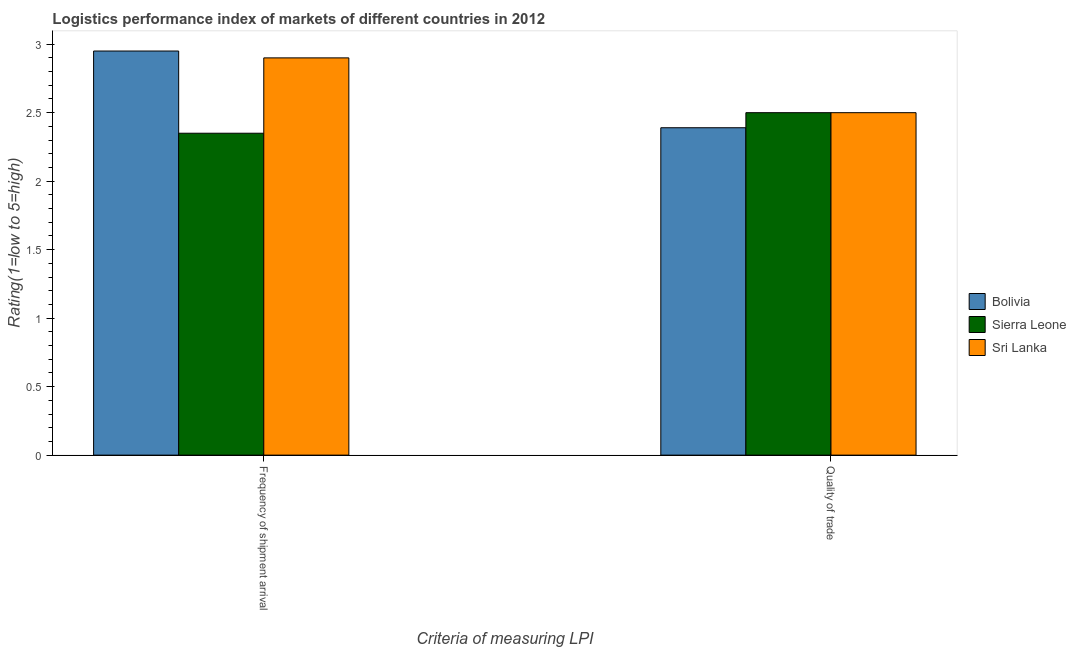How many groups of bars are there?
Provide a short and direct response. 2. Are the number of bars per tick equal to the number of legend labels?
Ensure brevity in your answer.  Yes. Are the number of bars on each tick of the X-axis equal?
Give a very brief answer. Yes. How many bars are there on the 2nd tick from the right?
Offer a terse response. 3. What is the label of the 1st group of bars from the left?
Offer a terse response. Frequency of shipment arrival. What is the lpi quality of trade in Sri Lanka?
Offer a very short reply. 2.5. Across all countries, what is the minimum lpi quality of trade?
Provide a short and direct response. 2.39. In which country was the lpi quality of trade maximum?
Give a very brief answer. Sierra Leone. In which country was the lpi quality of trade minimum?
Offer a terse response. Bolivia. What is the total lpi quality of trade in the graph?
Ensure brevity in your answer.  7.39. What is the difference between the lpi quality of trade in Bolivia and the lpi of frequency of shipment arrival in Sierra Leone?
Your response must be concise. 0.04. What is the average lpi quality of trade per country?
Give a very brief answer. 2.46. What is the difference between the lpi quality of trade and lpi of frequency of shipment arrival in Sierra Leone?
Your answer should be very brief. 0.15. What is the ratio of the lpi quality of trade in Bolivia to that in Sri Lanka?
Offer a terse response. 0.96. What does the 2nd bar from the left in Quality of trade represents?
Keep it short and to the point. Sierra Leone. What does the 2nd bar from the right in Frequency of shipment arrival represents?
Ensure brevity in your answer.  Sierra Leone. How many bars are there?
Offer a terse response. 6. Are all the bars in the graph horizontal?
Give a very brief answer. No. Does the graph contain grids?
Make the answer very short. No. Where does the legend appear in the graph?
Offer a terse response. Center right. What is the title of the graph?
Keep it short and to the point. Logistics performance index of markets of different countries in 2012. What is the label or title of the X-axis?
Ensure brevity in your answer.  Criteria of measuring LPI. What is the label or title of the Y-axis?
Your response must be concise. Rating(1=low to 5=high). What is the Rating(1=low to 5=high) in Bolivia in Frequency of shipment arrival?
Your answer should be very brief. 2.95. What is the Rating(1=low to 5=high) in Sierra Leone in Frequency of shipment arrival?
Ensure brevity in your answer.  2.35. What is the Rating(1=low to 5=high) in Bolivia in Quality of trade?
Give a very brief answer. 2.39. Across all Criteria of measuring LPI, what is the maximum Rating(1=low to 5=high) in Bolivia?
Ensure brevity in your answer.  2.95. Across all Criteria of measuring LPI, what is the maximum Rating(1=low to 5=high) in Sri Lanka?
Ensure brevity in your answer.  2.9. Across all Criteria of measuring LPI, what is the minimum Rating(1=low to 5=high) in Bolivia?
Your answer should be very brief. 2.39. Across all Criteria of measuring LPI, what is the minimum Rating(1=low to 5=high) in Sierra Leone?
Offer a very short reply. 2.35. What is the total Rating(1=low to 5=high) in Bolivia in the graph?
Provide a short and direct response. 5.34. What is the total Rating(1=low to 5=high) of Sierra Leone in the graph?
Offer a very short reply. 4.85. What is the difference between the Rating(1=low to 5=high) of Bolivia in Frequency of shipment arrival and that in Quality of trade?
Keep it short and to the point. 0.56. What is the difference between the Rating(1=low to 5=high) of Sierra Leone in Frequency of shipment arrival and that in Quality of trade?
Your response must be concise. -0.15. What is the difference between the Rating(1=low to 5=high) of Bolivia in Frequency of shipment arrival and the Rating(1=low to 5=high) of Sierra Leone in Quality of trade?
Offer a terse response. 0.45. What is the difference between the Rating(1=low to 5=high) of Bolivia in Frequency of shipment arrival and the Rating(1=low to 5=high) of Sri Lanka in Quality of trade?
Ensure brevity in your answer.  0.45. What is the average Rating(1=low to 5=high) of Bolivia per Criteria of measuring LPI?
Provide a succinct answer. 2.67. What is the average Rating(1=low to 5=high) of Sierra Leone per Criteria of measuring LPI?
Your response must be concise. 2.42. What is the difference between the Rating(1=low to 5=high) in Bolivia and Rating(1=low to 5=high) in Sierra Leone in Frequency of shipment arrival?
Provide a succinct answer. 0.6. What is the difference between the Rating(1=low to 5=high) in Sierra Leone and Rating(1=low to 5=high) in Sri Lanka in Frequency of shipment arrival?
Your response must be concise. -0.55. What is the difference between the Rating(1=low to 5=high) of Bolivia and Rating(1=low to 5=high) of Sierra Leone in Quality of trade?
Offer a terse response. -0.11. What is the difference between the Rating(1=low to 5=high) in Bolivia and Rating(1=low to 5=high) in Sri Lanka in Quality of trade?
Offer a terse response. -0.11. What is the ratio of the Rating(1=low to 5=high) in Bolivia in Frequency of shipment arrival to that in Quality of trade?
Provide a succinct answer. 1.23. What is the ratio of the Rating(1=low to 5=high) in Sierra Leone in Frequency of shipment arrival to that in Quality of trade?
Ensure brevity in your answer.  0.94. What is the ratio of the Rating(1=low to 5=high) in Sri Lanka in Frequency of shipment arrival to that in Quality of trade?
Your answer should be compact. 1.16. What is the difference between the highest and the second highest Rating(1=low to 5=high) of Bolivia?
Make the answer very short. 0.56. What is the difference between the highest and the second highest Rating(1=low to 5=high) of Sri Lanka?
Keep it short and to the point. 0.4. What is the difference between the highest and the lowest Rating(1=low to 5=high) in Bolivia?
Make the answer very short. 0.56. What is the difference between the highest and the lowest Rating(1=low to 5=high) of Sierra Leone?
Offer a terse response. 0.15. What is the difference between the highest and the lowest Rating(1=low to 5=high) of Sri Lanka?
Give a very brief answer. 0.4. 